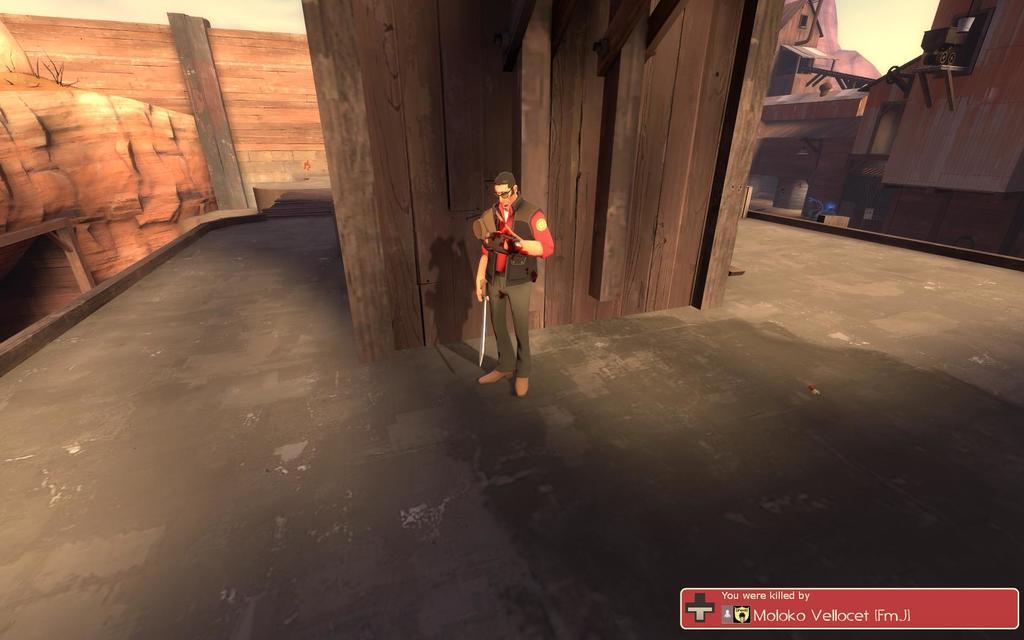Could you give a brief overview of what you see in this image? In this image we can see an animated picture of a person holding a sword in his hand is standing on the ground. In the background, we can see a group of buildings with windows and roofs, mountains, some wood pieces and the sky. At the bottom of the image we can see some text. 